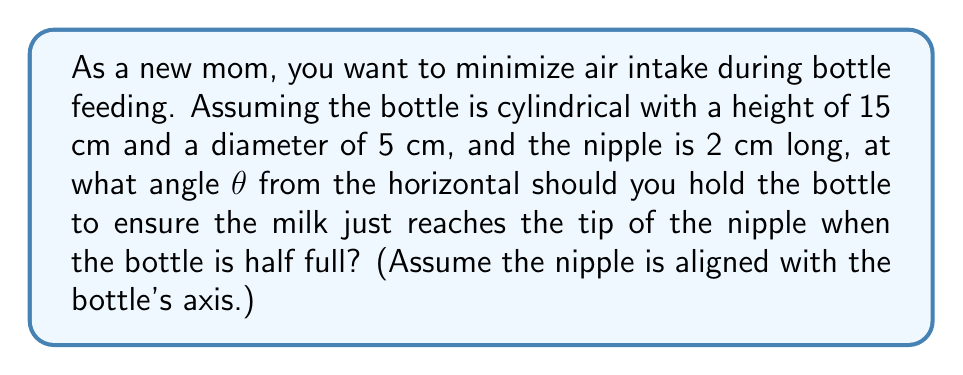Can you answer this question? Let's approach this step-by-step:

1) First, we need to find the volume of milk when the bottle is half full:
   Volume = $\frac{1}{2} \pi r^2 h = \frac{1}{2} \pi (2.5\text{ cm})^2 (15\text{ cm}) = 147.26\text{ cm}^3$

2) Now, we need to find the length of the milk surface in the tilted bottle. Let's call this length $L$. When tilted, the cross-section of the milk forms a right triangle with the bottle's base.

3) The volume of this triangular prism of milk is:
   $V = \frac{1}{2} L \cdot d \cdot w$
   where $d$ is the diameter and $w$ is the width of the bottle.

4) Substituting known values:
   $147.26 = \frac{1}{2} L \cdot 5 \cdot 5$
   $L = 11.78\text{ cm}$

5) In the right triangle formed by the milk surface and the bottle's axis:
   $\tan \theta = \frac{13}{11.78} = 1.1036$
   where 13 cm is the distance from the base of the bottle to the tip of the nipple (15 cm - 2 cm).

6) Therefore:
   $\theta = \arctan(1.1036) = 47.81°$

[asy]
import geometry;

size(200);
pair A=(0,0), B=(0,15), C=(5,0), D=(5,15);
pair E=(0,13), F=(5,13);
pair G=(0,11.78);

draw(A--B--D--C--cycle);
draw(E--F,dashed);
draw(A--G);

label("15 cm", (5.5,7.5), E);
label("13 cm", (5.5,6.5), E);
label("11.78 cm", (-0.5,5.89), W);
label("θ", (0.5,0.5), NE);

dot(E);
[/asy]
Answer: $47.81°$ 